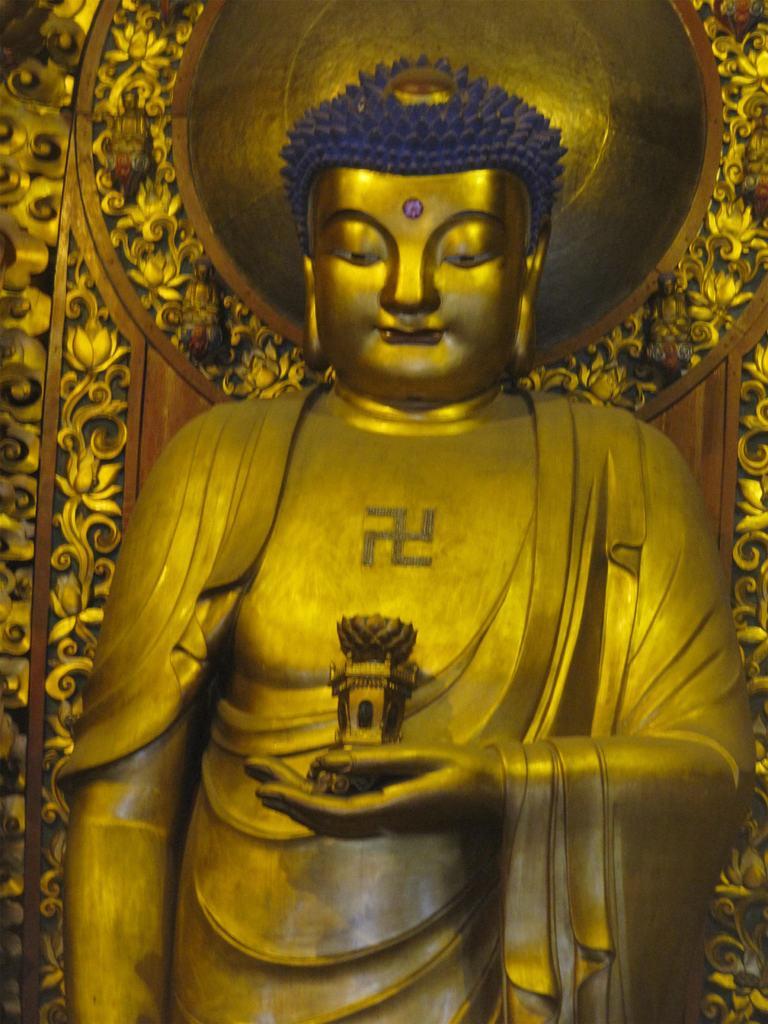How would you summarize this image in a sentence or two? This is the picture of a statue to which there is thing in the hand and it is in golden color and has a crown which is in blue color. 